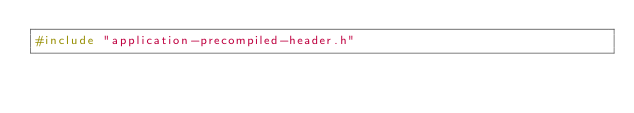<code> <loc_0><loc_0><loc_500><loc_500><_C++_>#include "application-precompiled-header.h"</code> 